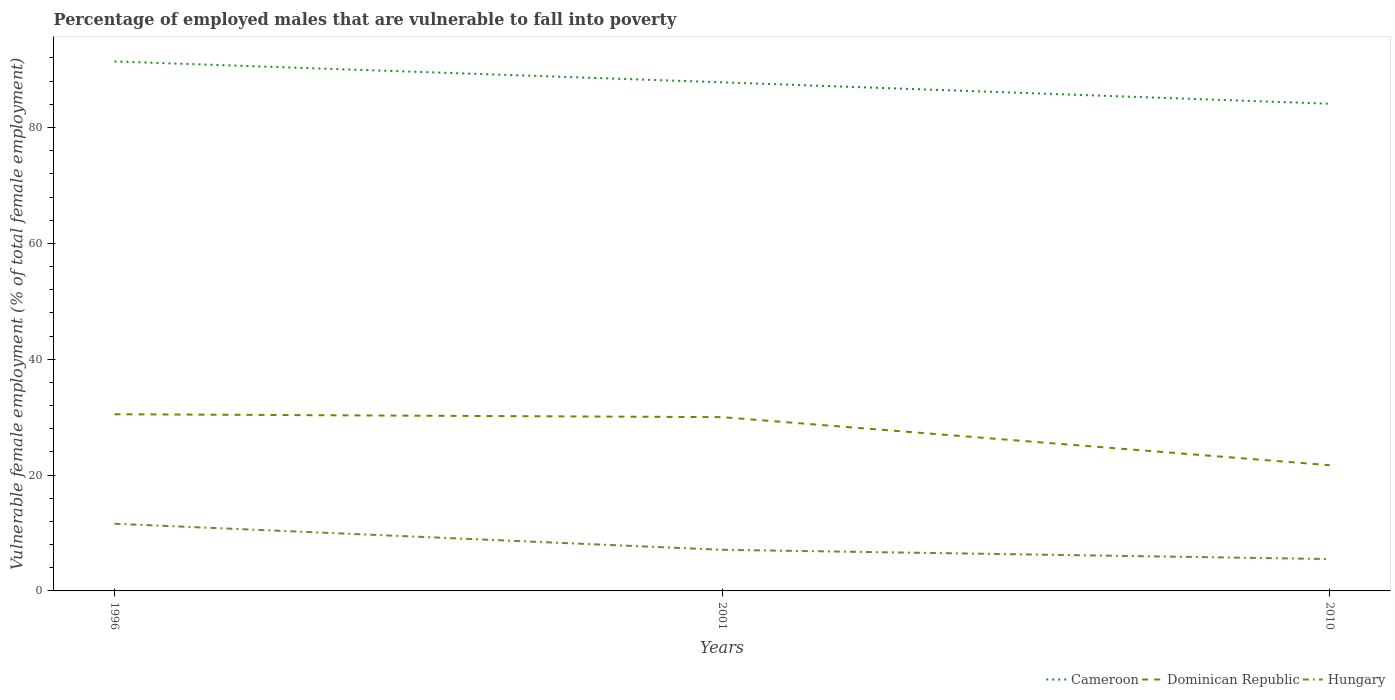How many different coloured lines are there?
Your answer should be very brief. 3. In which year was the percentage of employed males who are vulnerable to fall into poverty in Hungary maximum?
Keep it short and to the point. 2010. What is the total percentage of employed males who are vulnerable to fall into poverty in Hungary in the graph?
Offer a terse response. 1.6. What is the difference between the highest and the second highest percentage of employed males who are vulnerable to fall into poverty in Hungary?
Your answer should be very brief. 6.1. What is the difference between the highest and the lowest percentage of employed males who are vulnerable to fall into poverty in Cameroon?
Keep it short and to the point. 2. Are the values on the major ticks of Y-axis written in scientific E-notation?
Keep it short and to the point. No. Does the graph contain grids?
Your answer should be compact. No. How many legend labels are there?
Provide a short and direct response. 3. What is the title of the graph?
Offer a terse response. Percentage of employed males that are vulnerable to fall into poverty. What is the label or title of the X-axis?
Offer a very short reply. Years. What is the label or title of the Y-axis?
Your response must be concise. Vulnerable female employment (% of total female employment). What is the Vulnerable female employment (% of total female employment) in Cameroon in 1996?
Provide a short and direct response. 91.4. What is the Vulnerable female employment (% of total female employment) in Dominican Republic in 1996?
Provide a succinct answer. 30.5. What is the Vulnerable female employment (% of total female employment) of Hungary in 1996?
Your answer should be very brief. 11.6. What is the Vulnerable female employment (% of total female employment) of Cameroon in 2001?
Your answer should be compact. 87.8. What is the Vulnerable female employment (% of total female employment) of Dominican Republic in 2001?
Give a very brief answer. 30. What is the Vulnerable female employment (% of total female employment) of Hungary in 2001?
Give a very brief answer. 7.1. What is the Vulnerable female employment (% of total female employment) of Cameroon in 2010?
Make the answer very short. 84.1. What is the Vulnerable female employment (% of total female employment) of Dominican Republic in 2010?
Give a very brief answer. 21.7. Across all years, what is the maximum Vulnerable female employment (% of total female employment) in Cameroon?
Your answer should be compact. 91.4. Across all years, what is the maximum Vulnerable female employment (% of total female employment) of Dominican Republic?
Offer a terse response. 30.5. Across all years, what is the maximum Vulnerable female employment (% of total female employment) in Hungary?
Offer a very short reply. 11.6. Across all years, what is the minimum Vulnerable female employment (% of total female employment) in Cameroon?
Provide a short and direct response. 84.1. Across all years, what is the minimum Vulnerable female employment (% of total female employment) in Dominican Republic?
Ensure brevity in your answer.  21.7. What is the total Vulnerable female employment (% of total female employment) in Cameroon in the graph?
Give a very brief answer. 263.3. What is the total Vulnerable female employment (% of total female employment) of Dominican Republic in the graph?
Offer a terse response. 82.2. What is the total Vulnerable female employment (% of total female employment) of Hungary in the graph?
Provide a short and direct response. 24.2. What is the difference between the Vulnerable female employment (% of total female employment) of Dominican Republic in 1996 and that in 2001?
Provide a succinct answer. 0.5. What is the difference between the Vulnerable female employment (% of total female employment) of Cameroon in 1996 and that in 2010?
Your answer should be compact. 7.3. What is the difference between the Vulnerable female employment (% of total female employment) of Hungary in 1996 and that in 2010?
Offer a terse response. 6.1. What is the difference between the Vulnerable female employment (% of total female employment) in Dominican Republic in 2001 and that in 2010?
Ensure brevity in your answer.  8.3. What is the difference between the Vulnerable female employment (% of total female employment) of Cameroon in 1996 and the Vulnerable female employment (% of total female employment) of Dominican Republic in 2001?
Your answer should be compact. 61.4. What is the difference between the Vulnerable female employment (% of total female employment) in Cameroon in 1996 and the Vulnerable female employment (% of total female employment) in Hungary in 2001?
Your response must be concise. 84.3. What is the difference between the Vulnerable female employment (% of total female employment) of Dominican Republic in 1996 and the Vulnerable female employment (% of total female employment) of Hungary in 2001?
Give a very brief answer. 23.4. What is the difference between the Vulnerable female employment (% of total female employment) in Cameroon in 1996 and the Vulnerable female employment (% of total female employment) in Dominican Republic in 2010?
Your answer should be compact. 69.7. What is the difference between the Vulnerable female employment (% of total female employment) in Cameroon in 1996 and the Vulnerable female employment (% of total female employment) in Hungary in 2010?
Make the answer very short. 85.9. What is the difference between the Vulnerable female employment (% of total female employment) of Dominican Republic in 1996 and the Vulnerable female employment (% of total female employment) of Hungary in 2010?
Provide a succinct answer. 25. What is the difference between the Vulnerable female employment (% of total female employment) in Cameroon in 2001 and the Vulnerable female employment (% of total female employment) in Dominican Republic in 2010?
Keep it short and to the point. 66.1. What is the difference between the Vulnerable female employment (% of total female employment) of Cameroon in 2001 and the Vulnerable female employment (% of total female employment) of Hungary in 2010?
Make the answer very short. 82.3. What is the average Vulnerable female employment (% of total female employment) in Cameroon per year?
Your answer should be very brief. 87.77. What is the average Vulnerable female employment (% of total female employment) of Dominican Republic per year?
Your answer should be very brief. 27.4. What is the average Vulnerable female employment (% of total female employment) in Hungary per year?
Provide a short and direct response. 8.07. In the year 1996, what is the difference between the Vulnerable female employment (% of total female employment) in Cameroon and Vulnerable female employment (% of total female employment) in Dominican Republic?
Provide a succinct answer. 60.9. In the year 1996, what is the difference between the Vulnerable female employment (% of total female employment) of Cameroon and Vulnerable female employment (% of total female employment) of Hungary?
Give a very brief answer. 79.8. In the year 2001, what is the difference between the Vulnerable female employment (% of total female employment) of Cameroon and Vulnerable female employment (% of total female employment) of Dominican Republic?
Give a very brief answer. 57.8. In the year 2001, what is the difference between the Vulnerable female employment (% of total female employment) in Cameroon and Vulnerable female employment (% of total female employment) in Hungary?
Keep it short and to the point. 80.7. In the year 2001, what is the difference between the Vulnerable female employment (% of total female employment) in Dominican Republic and Vulnerable female employment (% of total female employment) in Hungary?
Your response must be concise. 22.9. In the year 2010, what is the difference between the Vulnerable female employment (% of total female employment) in Cameroon and Vulnerable female employment (% of total female employment) in Dominican Republic?
Ensure brevity in your answer.  62.4. In the year 2010, what is the difference between the Vulnerable female employment (% of total female employment) of Cameroon and Vulnerable female employment (% of total female employment) of Hungary?
Your response must be concise. 78.6. What is the ratio of the Vulnerable female employment (% of total female employment) of Cameroon in 1996 to that in 2001?
Make the answer very short. 1.04. What is the ratio of the Vulnerable female employment (% of total female employment) of Dominican Republic in 1996 to that in 2001?
Keep it short and to the point. 1.02. What is the ratio of the Vulnerable female employment (% of total female employment) in Hungary in 1996 to that in 2001?
Offer a terse response. 1.63. What is the ratio of the Vulnerable female employment (% of total female employment) of Cameroon in 1996 to that in 2010?
Provide a short and direct response. 1.09. What is the ratio of the Vulnerable female employment (% of total female employment) in Dominican Republic in 1996 to that in 2010?
Offer a very short reply. 1.41. What is the ratio of the Vulnerable female employment (% of total female employment) in Hungary in 1996 to that in 2010?
Offer a very short reply. 2.11. What is the ratio of the Vulnerable female employment (% of total female employment) in Cameroon in 2001 to that in 2010?
Your response must be concise. 1.04. What is the ratio of the Vulnerable female employment (% of total female employment) in Dominican Republic in 2001 to that in 2010?
Give a very brief answer. 1.38. What is the ratio of the Vulnerable female employment (% of total female employment) in Hungary in 2001 to that in 2010?
Offer a terse response. 1.29. What is the difference between the highest and the second highest Vulnerable female employment (% of total female employment) in Dominican Republic?
Keep it short and to the point. 0.5. What is the difference between the highest and the lowest Vulnerable female employment (% of total female employment) in Dominican Republic?
Keep it short and to the point. 8.8. What is the difference between the highest and the lowest Vulnerable female employment (% of total female employment) of Hungary?
Provide a short and direct response. 6.1. 